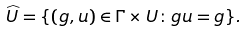Convert formula to latex. <formula><loc_0><loc_0><loc_500><loc_500>\widehat { U } = \{ ( g , u ) \in \Gamma \times U \colon g u = g \} .</formula> 